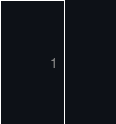<code> <loc_0><loc_0><loc_500><loc_500><_Kotlin_>
</code> 